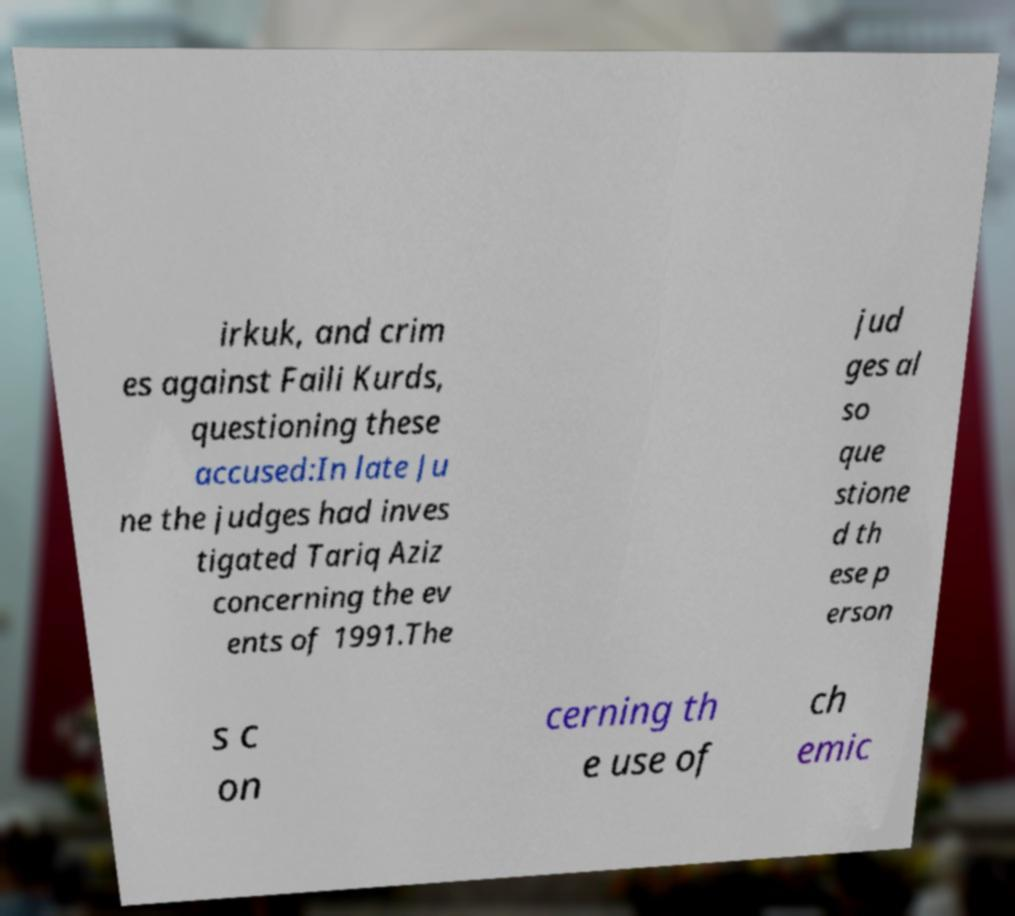Could you extract and type out the text from this image? irkuk, and crim es against Faili Kurds, questioning these accused:In late Ju ne the judges had inves tigated Tariq Aziz concerning the ev ents of 1991.The jud ges al so que stione d th ese p erson s c on cerning th e use of ch emic 